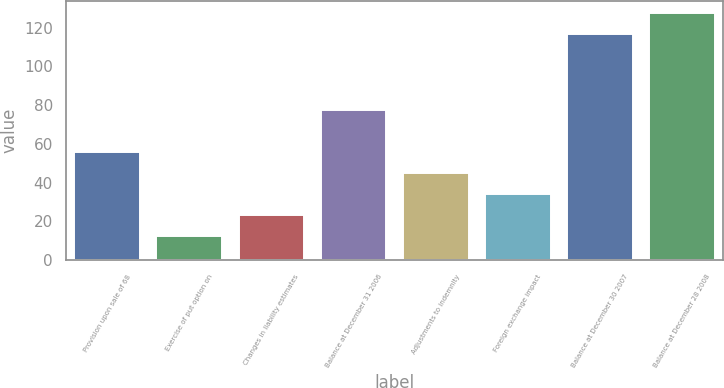Convert chart. <chart><loc_0><loc_0><loc_500><loc_500><bar_chart><fcel>Provision upon sale of 68<fcel>Exercise of put option on<fcel>Changes in liability estimates<fcel>Balance at December 31 2006<fcel>Adjustments to indemnity<fcel>Foreign exchange impact<fcel>Balance at December 30 2007<fcel>Balance at December 28 2008<nl><fcel>55.82<fcel>12.5<fcel>23.33<fcel>77.7<fcel>44.99<fcel>34.16<fcel>116.8<fcel>127.63<nl></chart> 